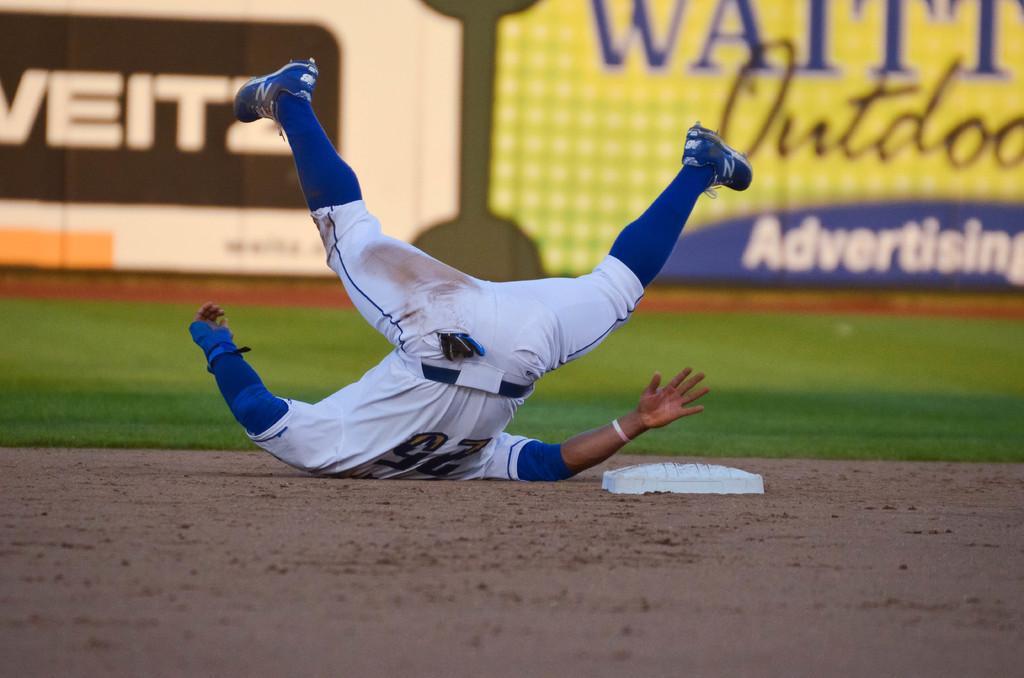Could you give a brief overview of what you see in this image? In this image we can see a man on the land. Beside the man, we can see one white color object. In the background, we can see grassy land and banners. The man is wearing white and blue color dress. 